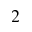<formula> <loc_0><loc_0><loc_500><loc_500>_ { 2 }</formula> 